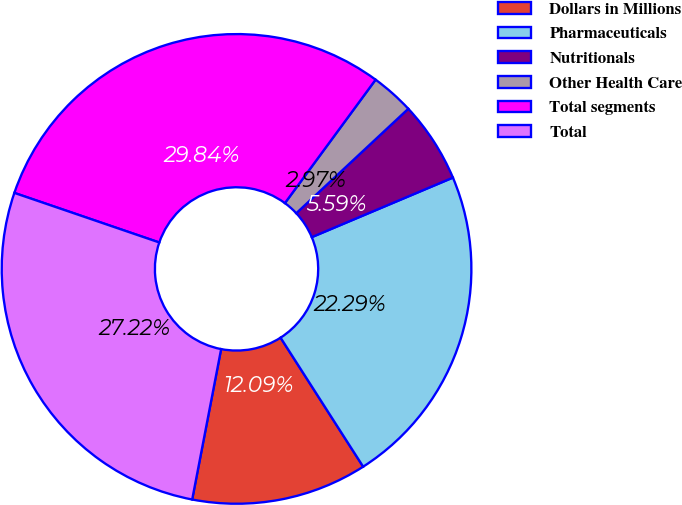Convert chart. <chart><loc_0><loc_0><loc_500><loc_500><pie_chart><fcel>Dollars in Millions<fcel>Pharmaceuticals<fcel>Nutritionals<fcel>Other Health Care<fcel>Total segments<fcel>Total<nl><fcel>12.09%<fcel>22.29%<fcel>5.59%<fcel>2.97%<fcel>29.84%<fcel>27.22%<nl></chart> 